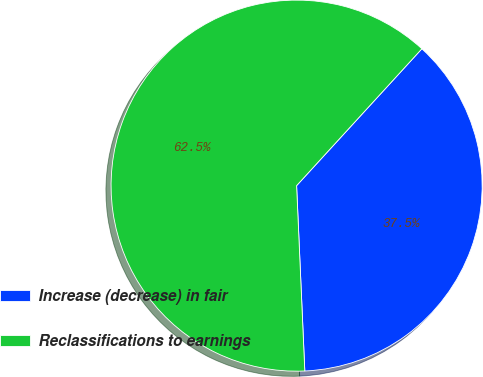Convert chart to OTSL. <chart><loc_0><loc_0><loc_500><loc_500><pie_chart><fcel>Increase (decrease) in fair<fcel>Reclassifications to earnings<nl><fcel>37.5%<fcel>62.5%<nl></chart> 